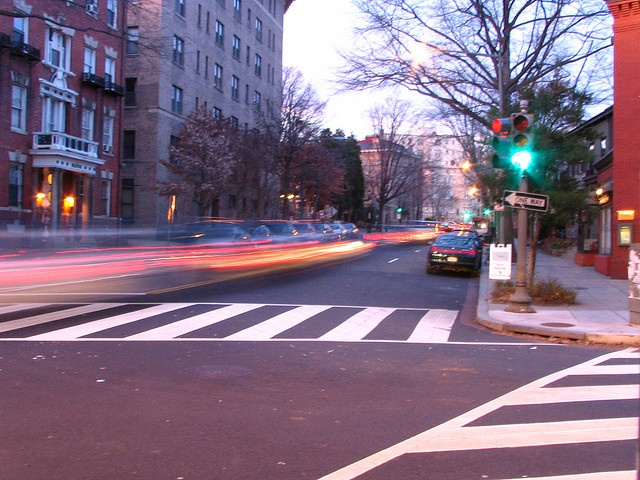Describe the objects in this image and their specific colors. I can see car in purple, black, gray, and navy tones, traffic light in purple, teal, black, and gray tones, car in purple, blue, navy, and darkblue tones, car in purple, gray, and darkgray tones, and car in purple, gray, blue, and darkblue tones in this image. 